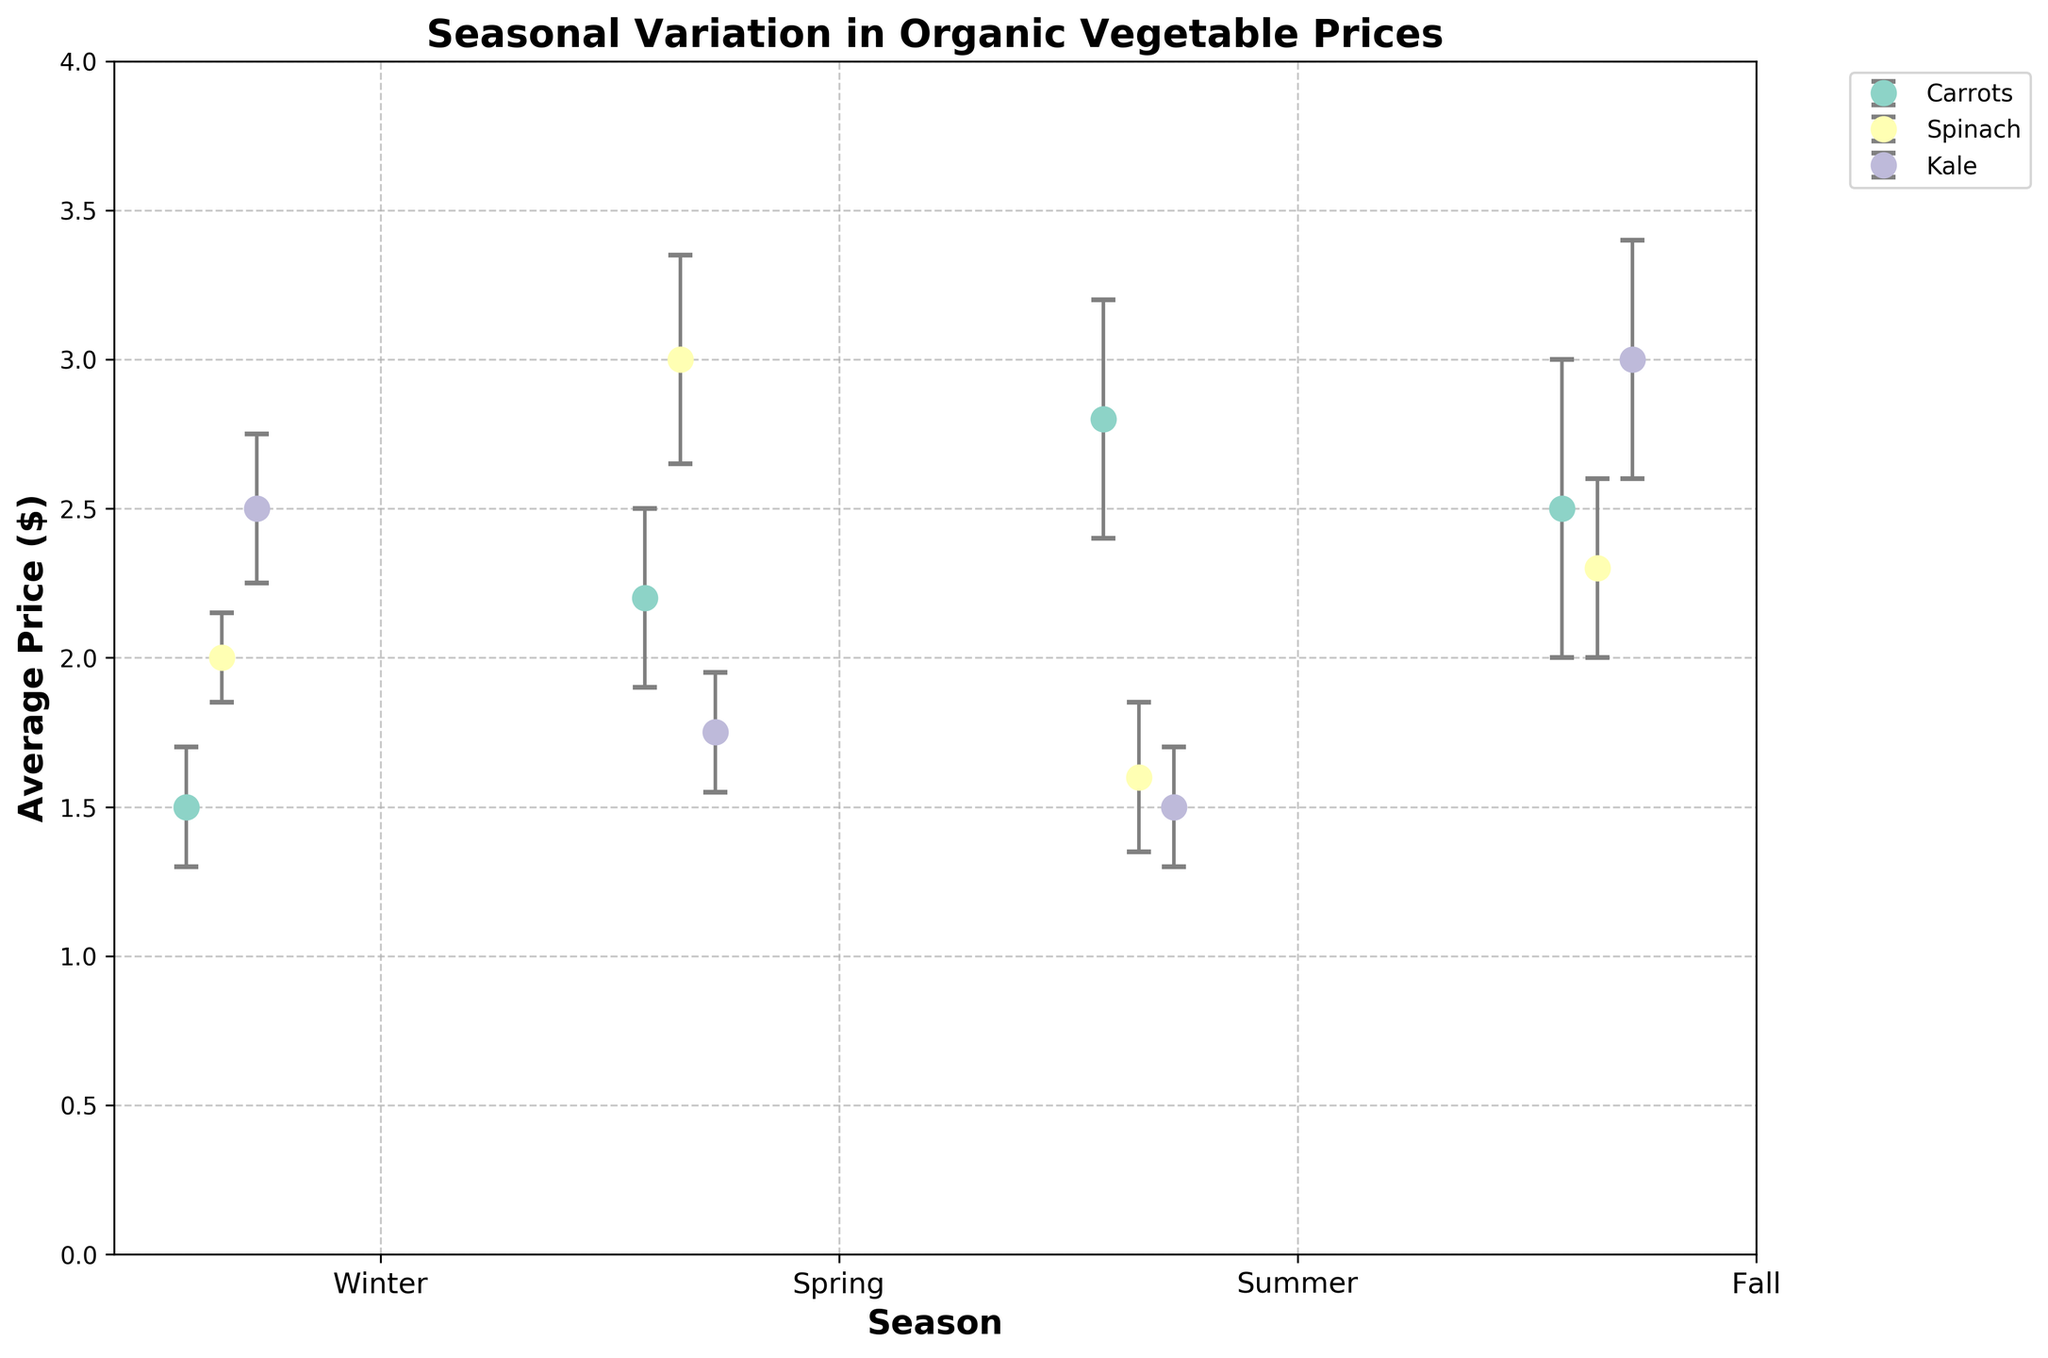What is the title of the figure? The title of the figure is written at the top of the plot.
Answer: Seasonal Variation in Organic Vegetable Prices What is the average price of Spinach in Winter? Locate the Winter season and find the dot representing Spinach. The dot is at an average price of 2.00.
Answer: 2.00 Which vegetable has the highest average price in Spring? Identify the dots for Spring and compare the average prices. Asparagus has the highest average price at 3.00.
Answer: Asparagus What is the range of average prices for vegetables in Fall? Find the highest and lowest average prices in Fall, which are for Brussel Sprouts (3.00) and Sweet Potatoes (2.30) respectively. The range is 3.00 - 2.30.
Answer: 0.70 Which season shows the highest variation in the prices of its vegetables? Variation can be assessed by looking at the error bars. Fall has the most extended error bars, especially for Pumpkins and Brussel Sprouts, indicating the highest variation.
Answer: Fall Is the average price of Kale in Winter higher than the average price of Radishes in Spring? Compare the average price of Kale in Winter (2.50) with Radishes in Spring (1.75). Kale's price is higher.
Answer: Yes What is the total number of unique vegetables displayed in the plot? Count the number of different vegetables listed on the legend; there are 12 unique vegetables.
Answer: 12 Which vegetable in Winter has the smallest standard deviation in price? In Winter, compare the standard deviations of Carrots (0.20), Spinach (0.15), and Kale (0.25). Spinach has the smallest standard deviation.
Answer: Spinach Are there any vegetables that appear in multiple seasons? Check if any vegetables are repeated across different seasons. Each vegetable appears only in one specific season.
Answer: No What is the average price of vegetables in Summer? Sum the average prices of Tomatoes (2.80), Zucchini (1.60), and Cucumbers (1.50) and divide by 3. (2.80 + 1.60 + 1.50) / 3 = 1.96.
Answer: 1.96 